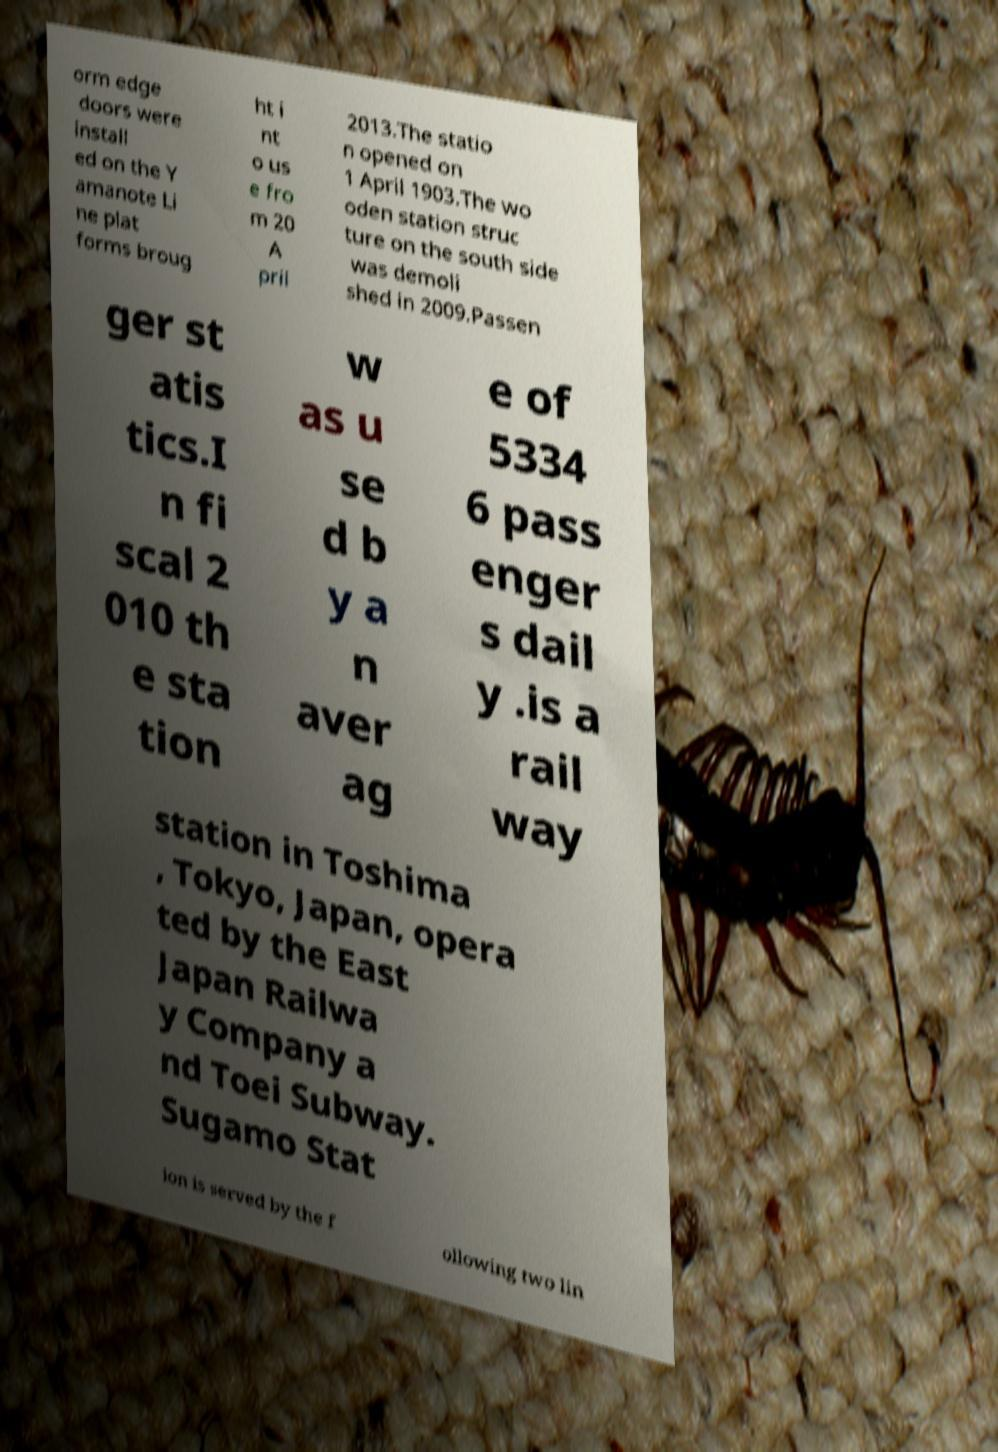What messages or text are displayed in this image? I need them in a readable, typed format. orm edge doors were install ed on the Y amanote Li ne plat forms broug ht i nt o us e fro m 20 A pril 2013.The statio n opened on 1 April 1903.The wo oden station struc ture on the south side was demoli shed in 2009.Passen ger st atis tics.I n fi scal 2 010 th e sta tion w as u se d b y a n aver ag e of 5334 6 pass enger s dail y .is a rail way station in Toshima , Tokyo, Japan, opera ted by the East Japan Railwa y Company a nd Toei Subway. Sugamo Stat ion is served by the f ollowing two lin 